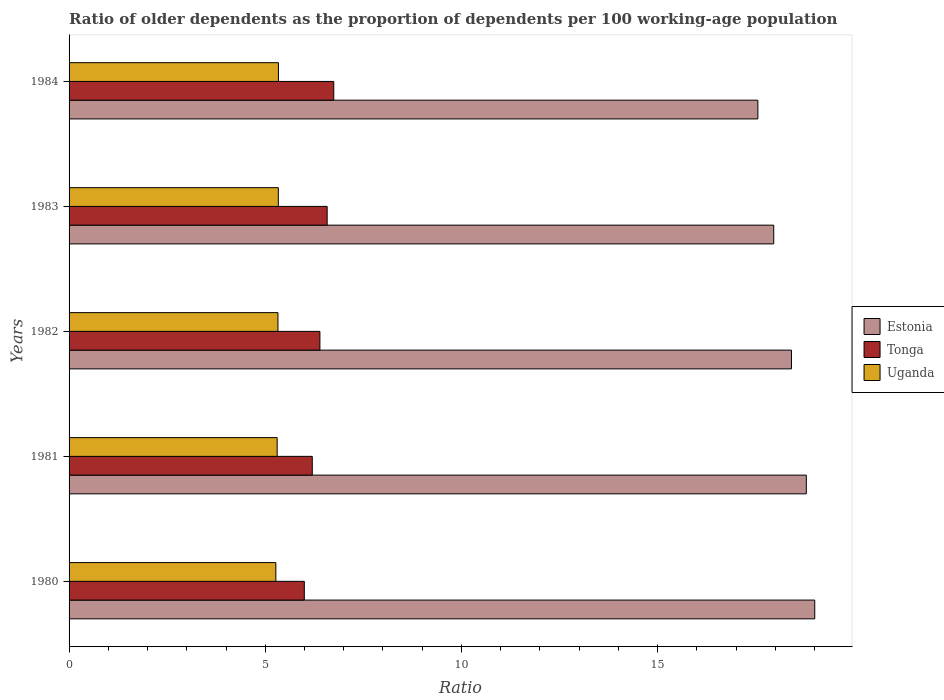How many different coloured bars are there?
Provide a short and direct response. 3. How many groups of bars are there?
Provide a succinct answer. 5. Are the number of bars on each tick of the Y-axis equal?
Provide a succinct answer. Yes. How many bars are there on the 5th tick from the bottom?
Offer a very short reply. 3. What is the age dependency ratio(old) in Estonia in 1981?
Offer a terse response. 18.79. Across all years, what is the maximum age dependency ratio(old) in Uganda?
Give a very brief answer. 5.34. Across all years, what is the minimum age dependency ratio(old) in Uganda?
Keep it short and to the point. 5.27. In which year was the age dependency ratio(old) in Uganda maximum?
Ensure brevity in your answer.  1984. In which year was the age dependency ratio(old) in Estonia minimum?
Offer a very short reply. 1984. What is the total age dependency ratio(old) in Uganda in the graph?
Your answer should be compact. 26.57. What is the difference between the age dependency ratio(old) in Estonia in 1981 and that in 1982?
Provide a short and direct response. 0.38. What is the difference between the age dependency ratio(old) in Tonga in 1980 and the age dependency ratio(old) in Uganda in 1984?
Your answer should be very brief. 0.66. What is the average age dependency ratio(old) in Tonga per year?
Your answer should be compact. 6.38. In the year 1981, what is the difference between the age dependency ratio(old) in Uganda and age dependency ratio(old) in Estonia?
Your response must be concise. -13.49. In how many years, is the age dependency ratio(old) in Uganda greater than 15 ?
Keep it short and to the point. 0. What is the ratio of the age dependency ratio(old) in Tonga in 1980 to that in 1984?
Keep it short and to the point. 0.89. What is the difference between the highest and the second highest age dependency ratio(old) in Uganda?
Provide a short and direct response. 0. What is the difference between the highest and the lowest age dependency ratio(old) in Estonia?
Give a very brief answer. 1.45. What does the 2nd bar from the top in 1982 represents?
Your answer should be very brief. Tonga. What does the 1st bar from the bottom in 1981 represents?
Give a very brief answer. Estonia. Is it the case that in every year, the sum of the age dependency ratio(old) in Uganda and age dependency ratio(old) in Estonia is greater than the age dependency ratio(old) in Tonga?
Provide a succinct answer. Yes. How many bars are there?
Provide a short and direct response. 15. Are all the bars in the graph horizontal?
Give a very brief answer. Yes. What is the difference between two consecutive major ticks on the X-axis?
Your response must be concise. 5. Are the values on the major ticks of X-axis written in scientific E-notation?
Your answer should be very brief. No. Does the graph contain any zero values?
Make the answer very short. No. Where does the legend appear in the graph?
Make the answer very short. Center right. How many legend labels are there?
Keep it short and to the point. 3. How are the legend labels stacked?
Your answer should be compact. Vertical. What is the title of the graph?
Your answer should be compact. Ratio of older dependents as the proportion of dependents per 100 working-age population. Does "Italy" appear as one of the legend labels in the graph?
Provide a succinct answer. No. What is the label or title of the X-axis?
Offer a very short reply. Ratio. What is the Ratio of Estonia in 1980?
Provide a short and direct response. 19. What is the Ratio in Tonga in 1980?
Give a very brief answer. 6. What is the Ratio in Uganda in 1980?
Keep it short and to the point. 5.27. What is the Ratio of Estonia in 1981?
Your answer should be compact. 18.79. What is the Ratio in Tonga in 1981?
Your response must be concise. 6.2. What is the Ratio in Uganda in 1981?
Your answer should be compact. 5.3. What is the Ratio of Estonia in 1982?
Provide a short and direct response. 18.41. What is the Ratio of Tonga in 1982?
Your answer should be very brief. 6.39. What is the Ratio in Uganda in 1982?
Provide a succinct answer. 5.32. What is the Ratio in Estonia in 1983?
Offer a terse response. 17.96. What is the Ratio in Tonga in 1983?
Provide a succinct answer. 6.58. What is the Ratio in Uganda in 1983?
Your answer should be compact. 5.33. What is the Ratio in Estonia in 1984?
Ensure brevity in your answer.  17.55. What is the Ratio of Tonga in 1984?
Offer a terse response. 6.75. What is the Ratio in Uganda in 1984?
Your response must be concise. 5.34. Across all years, what is the maximum Ratio of Estonia?
Make the answer very short. 19. Across all years, what is the maximum Ratio of Tonga?
Your response must be concise. 6.75. Across all years, what is the maximum Ratio of Uganda?
Your answer should be very brief. 5.34. Across all years, what is the minimum Ratio of Estonia?
Make the answer very short. 17.55. Across all years, what is the minimum Ratio in Tonga?
Provide a short and direct response. 6. Across all years, what is the minimum Ratio in Uganda?
Keep it short and to the point. 5.27. What is the total Ratio of Estonia in the graph?
Offer a terse response. 91.72. What is the total Ratio of Tonga in the graph?
Your answer should be very brief. 31.91. What is the total Ratio of Uganda in the graph?
Make the answer very short. 26.57. What is the difference between the Ratio in Estonia in 1980 and that in 1981?
Your answer should be compact. 0.21. What is the difference between the Ratio in Tonga in 1980 and that in 1981?
Offer a very short reply. -0.2. What is the difference between the Ratio of Uganda in 1980 and that in 1981?
Provide a succinct answer. -0.03. What is the difference between the Ratio in Estonia in 1980 and that in 1982?
Keep it short and to the point. 0.59. What is the difference between the Ratio in Tonga in 1980 and that in 1982?
Offer a terse response. -0.4. What is the difference between the Ratio in Uganda in 1980 and that in 1982?
Provide a succinct answer. -0.05. What is the difference between the Ratio in Estonia in 1980 and that in 1983?
Your answer should be very brief. 1.05. What is the difference between the Ratio in Tonga in 1980 and that in 1983?
Offer a terse response. -0.58. What is the difference between the Ratio in Uganda in 1980 and that in 1983?
Your answer should be very brief. -0.06. What is the difference between the Ratio of Estonia in 1980 and that in 1984?
Provide a succinct answer. 1.45. What is the difference between the Ratio of Tonga in 1980 and that in 1984?
Provide a succinct answer. -0.75. What is the difference between the Ratio in Uganda in 1980 and that in 1984?
Provide a short and direct response. -0.07. What is the difference between the Ratio in Estonia in 1981 and that in 1982?
Ensure brevity in your answer.  0.38. What is the difference between the Ratio in Tonga in 1981 and that in 1982?
Offer a terse response. -0.19. What is the difference between the Ratio of Uganda in 1981 and that in 1982?
Keep it short and to the point. -0.02. What is the difference between the Ratio of Estonia in 1981 and that in 1983?
Provide a succinct answer. 0.83. What is the difference between the Ratio in Tonga in 1981 and that in 1983?
Keep it short and to the point. -0.38. What is the difference between the Ratio in Uganda in 1981 and that in 1983?
Give a very brief answer. -0.03. What is the difference between the Ratio in Estonia in 1981 and that in 1984?
Keep it short and to the point. 1.24. What is the difference between the Ratio of Tonga in 1981 and that in 1984?
Provide a succinct answer. -0.55. What is the difference between the Ratio in Uganda in 1981 and that in 1984?
Make the answer very short. -0.03. What is the difference between the Ratio of Estonia in 1982 and that in 1983?
Make the answer very short. 0.45. What is the difference between the Ratio in Tonga in 1982 and that in 1983?
Your answer should be very brief. -0.19. What is the difference between the Ratio of Uganda in 1982 and that in 1983?
Your answer should be very brief. -0.01. What is the difference between the Ratio in Estonia in 1982 and that in 1984?
Offer a very short reply. 0.86. What is the difference between the Ratio of Tonga in 1982 and that in 1984?
Offer a terse response. -0.35. What is the difference between the Ratio in Uganda in 1982 and that in 1984?
Give a very brief answer. -0.01. What is the difference between the Ratio of Estonia in 1983 and that in 1984?
Your answer should be very brief. 0.4. What is the difference between the Ratio of Tonga in 1983 and that in 1984?
Ensure brevity in your answer.  -0.17. What is the difference between the Ratio in Uganda in 1983 and that in 1984?
Your answer should be compact. -0. What is the difference between the Ratio in Estonia in 1980 and the Ratio in Tonga in 1981?
Provide a short and direct response. 12.81. What is the difference between the Ratio of Estonia in 1980 and the Ratio of Uganda in 1981?
Your answer should be very brief. 13.7. What is the difference between the Ratio in Tonga in 1980 and the Ratio in Uganda in 1981?
Offer a terse response. 0.69. What is the difference between the Ratio in Estonia in 1980 and the Ratio in Tonga in 1982?
Ensure brevity in your answer.  12.61. What is the difference between the Ratio in Estonia in 1980 and the Ratio in Uganda in 1982?
Ensure brevity in your answer.  13.68. What is the difference between the Ratio in Tonga in 1980 and the Ratio in Uganda in 1982?
Make the answer very short. 0.67. What is the difference between the Ratio of Estonia in 1980 and the Ratio of Tonga in 1983?
Give a very brief answer. 12.43. What is the difference between the Ratio in Estonia in 1980 and the Ratio in Uganda in 1983?
Make the answer very short. 13.67. What is the difference between the Ratio of Tonga in 1980 and the Ratio of Uganda in 1983?
Offer a terse response. 0.66. What is the difference between the Ratio of Estonia in 1980 and the Ratio of Tonga in 1984?
Provide a short and direct response. 12.26. What is the difference between the Ratio of Estonia in 1980 and the Ratio of Uganda in 1984?
Offer a very short reply. 13.67. What is the difference between the Ratio in Tonga in 1980 and the Ratio in Uganda in 1984?
Make the answer very short. 0.66. What is the difference between the Ratio in Estonia in 1981 and the Ratio in Tonga in 1982?
Your response must be concise. 12.4. What is the difference between the Ratio of Estonia in 1981 and the Ratio of Uganda in 1982?
Make the answer very short. 13.47. What is the difference between the Ratio of Tonga in 1981 and the Ratio of Uganda in 1982?
Your answer should be compact. 0.88. What is the difference between the Ratio in Estonia in 1981 and the Ratio in Tonga in 1983?
Offer a very short reply. 12.21. What is the difference between the Ratio of Estonia in 1981 and the Ratio of Uganda in 1983?
Ensure brevity in your answer.  13.46. What is the difference between the Ratio of Tonga in 1981 and the Ratio of Uganda in 1983?
Ensure brevity in your answer.  0.87. What is the difference between the Ratio in Estonia in 1981 and the Ratio in Tonga in 1984?
Make the answer very short. 12.04. What is the difference between the Ratio in Estonia in 1981 and the Ratio in Uganda in 1984?
Offer a very short reply. 13.45. What is the difference between the Ratio of Tonga in 1981 and the Ratio of Uganda in 1984?
Ensure brevity in your answer.  0.86. What is the difference between the Ratio of Estonia in 1982 and the Ratio of Tonga in 1983?
Ensure brevity in your answer.  11.83. What is the difference between the Ratio in Estonia in 1982 and the Ratio in Uganda in 1983?
Your response must be concise. 13.08. What is the difference between the Ratio in Tonga in 1982 and the Ratio in Uganda in 1983?
Provide a short and direct response. 1.06. What is the difference between the Ratio in Estonia in 1982 and the Ratio in Tonga in 1984?
Keep it short and to the point. 11.67. What is the difference between the Ratio in Estonia in 1982 and the Ratio in Uganda in 1984?
Provide a succinct answer. 13.08. What is the difference between the Ratio in Tonga in 1982 and the Ratio in Uganda in 1984?
Provide a succinct answer. 1.06. What is the difference between the Ratio of Estonia in 1983 and the Ratio of Tonga in 1984?
Your answer should be compact. 11.21. What is the difference between the Ratio of Estonia in 1983 and the Ratio of Uganda in 1984?
Your answer should be compact. 12.62. What is the difference between the Ratio of Tonga in 1983 and the Ratio of Uganda in 1984?
Ensure brevity in your answer.  1.24. What is the average Ratio of Estonia per year?
Provide a succinct answer. 18.34. What is the average Ratio in Tonga per year?
Offer a terse response. 6.38. What is the average Ratio in Uganda per year?
Give a very brief answer. 5.31. In the year 1980, what is the difference between the Ratio of Estonia and Ratio of Tonga?
Your answer should be very brief. 13.01. In the year 1980, what is the difference between the Ratio of Estonia and Ratio of Uganda?
Offer a terse response. 13.73. In the year 1980, what is the difference between the Ratio of Tonga and Ratio of Uganda?
Your response must be concise. 0.73. In the year 1981, what is the difference between the Ratio of Estonia and Ratio of Tonga?
Offer a very short reply. 12.59. In the year 1981, what is the difference between the Ratio in Estonia and Ratio in Uganda?
Your answer should be compact. 13.49. In the year 1981, what is the difference between the Ratio of Tonga and Ratio of Uganda?
Offer a terse response. 0.9. In the year 1982, what is the difference between the Ratio in Estonia and Ratio in Tonga?
Make the answer very short. 12.02. In the year 1982, what is the difference between the Ratio in Estonia and Ratio in Uganda?
Offer a very short reply. 13.09. In the year 1982, what is the difference between the Ratio in Tonga and Ratio in Uganda?
Give a very brief answer. 1.07. In the year 1983, what is the difference between the Ratio of Estonia and Ratio of Tonga?
Your response must be concise. 11.38. In the year 1983, what is the difference between the Ratio in Estonia and Ratio in Uganda?
Give a very brief answer. 12.63. In the year 1983, what is the difference between the Ratio in Tonga and Ratio in Uganda?
Ensure brevity in your answer.  1.24. In the year 1984, what is the difference between the Ratio in Estonia and Ratio in Tonga?
Offer a very short reply. 10.81. In the year 1984, what is the difference between the Ratio in Estonia and Ratio in Uganda?
Your answer should be very brief. 12.22. In the year 1984, what is the difference between the Ratio in Tonga and Ratio in Uganda?
Provide a short and direct response. 1.41. What is the ratio of the Ratio of Estonia in 1980 to that in 1981?
Ensure brevity in your answer.  1.01. What is the ratio of the Ratio of Tonga in 1980 to that in 1981?
Your response must be concise. 0.97. What is the ratio of the Ratio in Estonia in 1980 to that in 1982?
Offer a terse response. 1.03. What is the ratio of the Ratio of Tonga in 1980 to that in 1982?
Your response must be concise. 0.94. What is the ratio of the Ratio in Uganda in 1980 to that in 1982?
Give a very brief answer. 0.99. What is the ratio of the Ratio of Estonia in 1980 to that in 1983?
Keep it short and to the point. 1.06. What is the ratio of the Ratio of Tonga in 1980 to that in 1983?
Provide a succinct answer. 0.91. What is the ratio of the Ratio of Estonia in 1980 to that in 1984?
Provide a succinct answer. 1.08. What is the ratio of the Ratio of Tonga in 1980 to that in 1984?
Make the answer very short. 0.89. What is the ratio of the Ratio in Uganda in 1980 to that in 1984?
Your response must be concise. 0.99. What is the ratio of the Ratio of Estonia in 1981 to that in 1982?
Make the answer very short. 1.02. What is the ratio of the Ratio in Tonga in 1981 to that in 1982?
Your answer should be compact. 0.97. What is the ratio of the Ratio in Estonia in 1981 to that in 1983?
Keep it short and to the point. 1.05. What is the ratio of the Ratio in Tonga in 1981 to that in 1983?
Your response must be concise. 0.94. What is the ratio of the Ratio of Uganda in 1981 to that in 1983?
Keep it short and to the point. 0.99. What is the ratio of the Ratio in Estonia in 1981 to that in 1984?
Ensure brevity in your answer.  1.07. What is the ratio of the Ratio in Tonga in 1981 to that in 1984?
Offer a very short reply. 0.92. What is the ratio of the Ratio in Uganda in 1981 to that in 1984?
Your answer should be very brief. 0.99. What is the ratio of the Ratio of Estonia in 1982 to that in 1983?
Your response must be concise. 1.03. What is the ratio of the Ratio in Tonga in 1982 to that in 1983?
Your answer should be compact. 0.97. What is the ratio of the Ratio of Uganda in 1982 to that in 1983?
Your answer should be very brief. 1. What is the ratio of the Ratio in Estonia in 1982 to that in 1984?
Make the answer very short. 1.05. What is the ratio of the Ratio in Tonga in 1982 to that in 1984?
Give a very brief answer. 0.95. What is the ratio of the Ratio of Tonga in 1983 to that in 1984?
Keep it short and to the point. 0.98. What is the ratio of the Ratio in Uganda in 1983 to that in 1984?
Provide a short and direct response. 1. What is the difference between the highest and the second highest Ratio of Estonia?
Provide a succinct answer. 0.21. What is the difference between the highest and the second highest Ratio of Tonga?
Your answer should be very brief. 0.17. What is the difference between the highest and the second highest Ratio in Uganda?
Provide a short and direct response. 0. What is the difference between the highest and the lowest Ratio in Estonia?
Offer a very short reply. 1.45. What is the difference between the highest and the lowest Ratio of Tonga?
Offer a very short reply. 0.75. What is the difference between the highest and the lowest Ratio in Uganda?
Offer a very short reply. 0.07. 